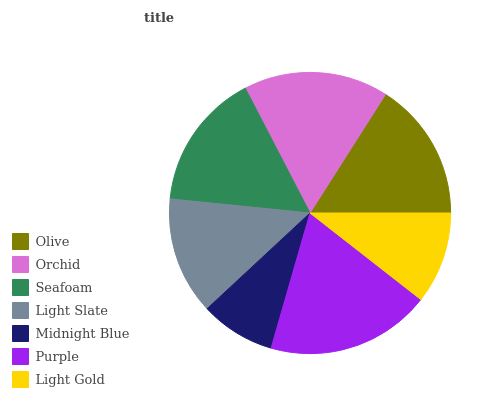Is Midnight Blue the minimum?
Answer yes or no. Yes. Is Purple the maximum?
Answer yes or no. Yes. Is Orchid the minimum?
Answer yes or no. No. Is Orchid the maximum?
Answer yes or no. No. Is Orchid greater than Olive?
Answer yes or no. Yes. Is Olive less than Orchid?
Answer yes or no. Yes. Is Olive greater than Orchid?
Answer yes or no. No. Is Orchid less than Olive?
Answer yes or no. No. Is Seafoam the high median?
Answer yes or no. Yes. Is Seafoam the low median?
Answer yes or no. Yes. Is Light Slate the high median?
Answer yes or no. No. Is Orchid the low median?
Answer yes or no. No. 